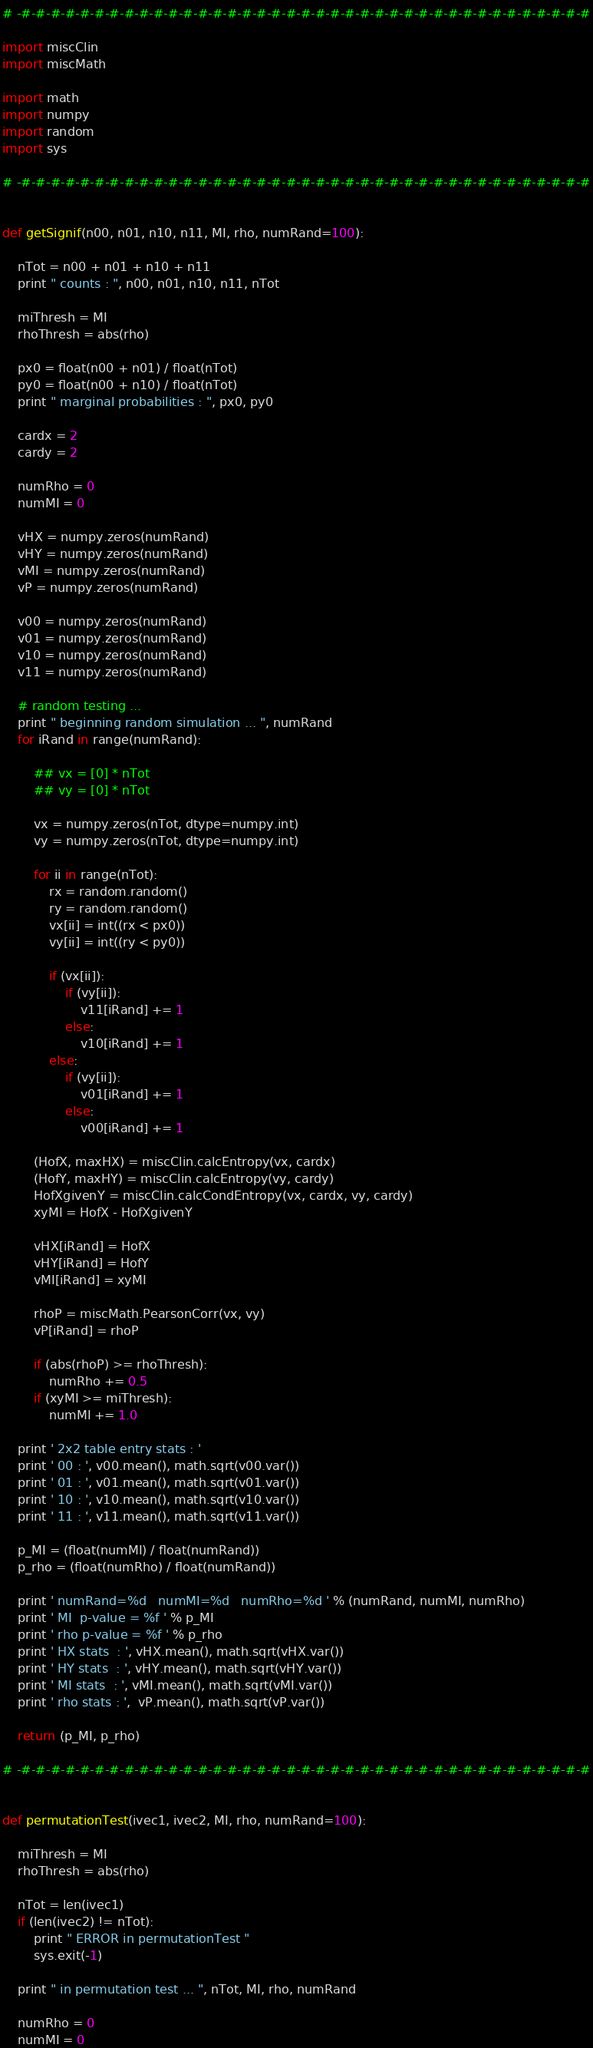<code> <loc_0><loc_0><loc_500><loc_500><_Python_># -#-#-#-#-#-#-#-#-#-#-#-#-#-#-#-#-#-#-#-#-#-#-#-#-#-#-#-#-#-#-#-#-#-#-#-#-#-#-#

import miscClin
import miscMath

import math
import numpy
import random
import sys

# -#-#-#-#-#-#-#-#-#-#-#-#-#-#-#-#-#-#-#-#-#-#-#-#-#-#-#-#-#-#-#-#-#-#-#-#-#-#-#


def getSignif(n00, n01, n10, n11, MI, rho, numRand=100):

    nTot = n00 + n01 + n10 + n11
    print " counts : ", n00, n01, n10, n11, nTot

    miThresh = MI
    rhoThresh = abs(rho)

    px0 = float(n00 + n01) / float(nTot)
    py0 = float(n00 + n10) / float(nTot)
    print " marginal probabilities : ", px0, py0

    cardx = 2
    cardy = 2

    numRho = 0
    numMI = 0

    vHX = numpy.zeros(numRand)
    vHY = numpy.zeros(numRand)
    vMI = numpy.zeros(numRand)
    vP = numpy.zeros(numRand)

    v00 = numpy.zeros(numRand)
    v01 = numpy.zeros(numRand)
    v10 = numpy.zeros(numRand)
    v11 = numpy.zeros(numRand)

    # random testing ...
    print " beginning random simulation ... ", numRand
    for iRand in range(numRand):

        ## vx = [0] * nTot
        ## vy = [0] * nTot

        vx = numpy.zeros(nTot, dtype=numpy.int)
        vy = numpy.zeros(nTot, dtype=numpy.int)

        for ii in range(nTot):
            rx = random.random()
            ry = random.random()
            vx[ii] = int((rx < px0))
            vy[ii] = int((ry < py0))

            if (vx[ii]):
                if (vy[ii]):
                    v11[iRand] += 1
                else:
                    v10[iRand] += 1
            else:
                if (vy[ii]):
                    v01[iRand] += 1
                else:
                    v00[iRand] += 1

        (HofX, maxHX) = miscClin.calcEntropy(vx, cardx)
        (HofY, maxHY) = miscClin.calcEntropy(vy, cardy)
        HofXgivenY = miscClin.calcCondEntropy(vx, cardx, vy, cardy)
        xyMI = HofX - HofXgivenY

        vHX[iRand] = HofX
        vHY[iRand] = HofY
        vMI[iRand] = xyMI

        rhoP = miscMath.PearsonCorr(vx, vy)
        vP[iRand] = rhoP

        if (abs(rhoP) >= rhoThresh):
            numRho += 0.5
        if (xyMI >= miThresh):
            numMI += 1.0

    print ' 2x2 table entry stats : '
    print ' 00 : ', v00.mean(), math.sqrt(v00.var())
    print ' 01 : ', v01.mean(), math.sqrt(v01.var())
    print ' 10 : ', v10.mean(), math.sqrt(v10.var())
    print ' 11 : ', v11.mean(), math.sqrt(v11.var())

    p_MI = (float(numMI) / float(numRand))
    p_rho = (float(numRho) / float(numRand))

    print ' numRand=%d   numMI=%d   numRho=%d ' % (numRand, numMI, numRho)
    print ' MI  p-value = %f ' % p_MI
    print ' rho p-value = %f ' % p_rho
    print ' HX stats  : ', vHX.mean(), math.sqrt(vHX.var())
    print ' HY stats  : ', vHY.mean(), math.sqrt(vHY.var())
    print ' MI stats  : ', vMI.mean(), math.sqrt(vMI.var())
    print ' rho stats : ',  vP.mean(), math.sqrt(vP.var())

    return (p_MI, p_rho)

# -#-#-#-#-#-#-#-#-#-#-#-#-#-#-#-#-#-#-#-#-#-#-#-#-#-#-#-#-#-#-#-#-#-#-#-#-#-#-#


def permutationTest(ivec1, ivec2, MI, rho, numRand=100):

    miThresh = MI
    rhoThresh = abs(rho)

    nTot = len(ivec1)
    if (len(ivec2) != nTot):
        print " ERROR in permutationTest "
        sys.exit(-1)

    print " in permutation test ... ", nTot, MI, rho, numRand

    numRho = 0
    numMI = 0
</code> 